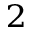Convert formula to latex. <formula><loc_0><loc_0><loc_500><loc_500>^ { 2 }</formula> 